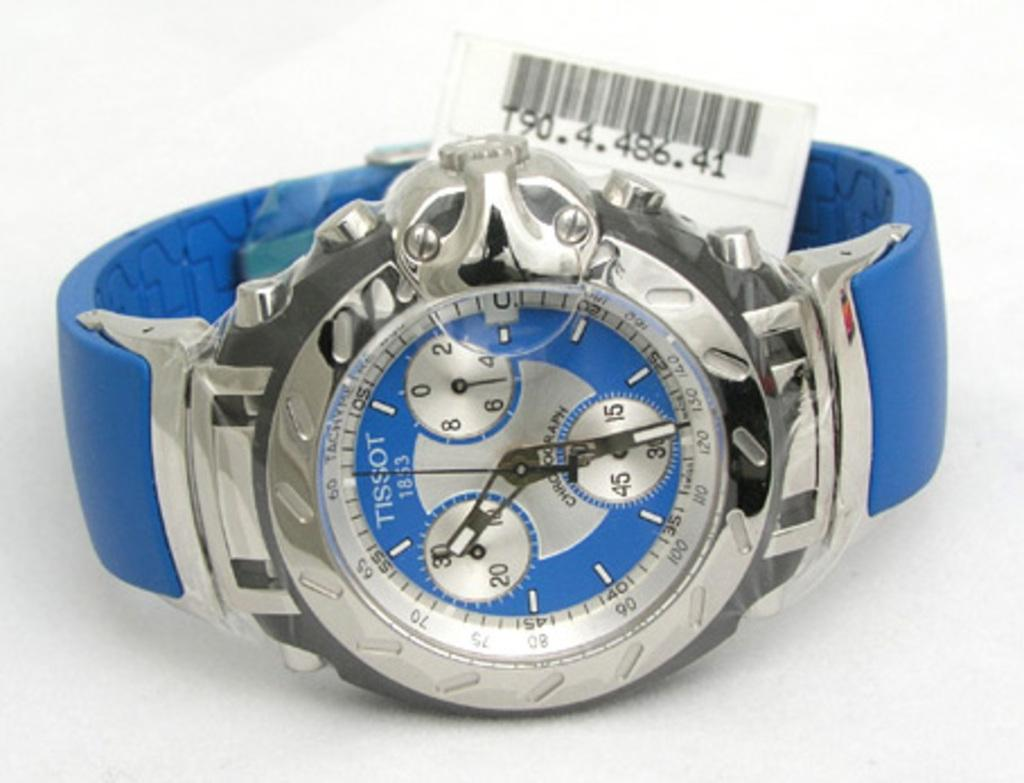<image>
Summarize the visual content of the image. The SKU number for a blue, Tissot, wrist watch on display is T90.4.486.41. 